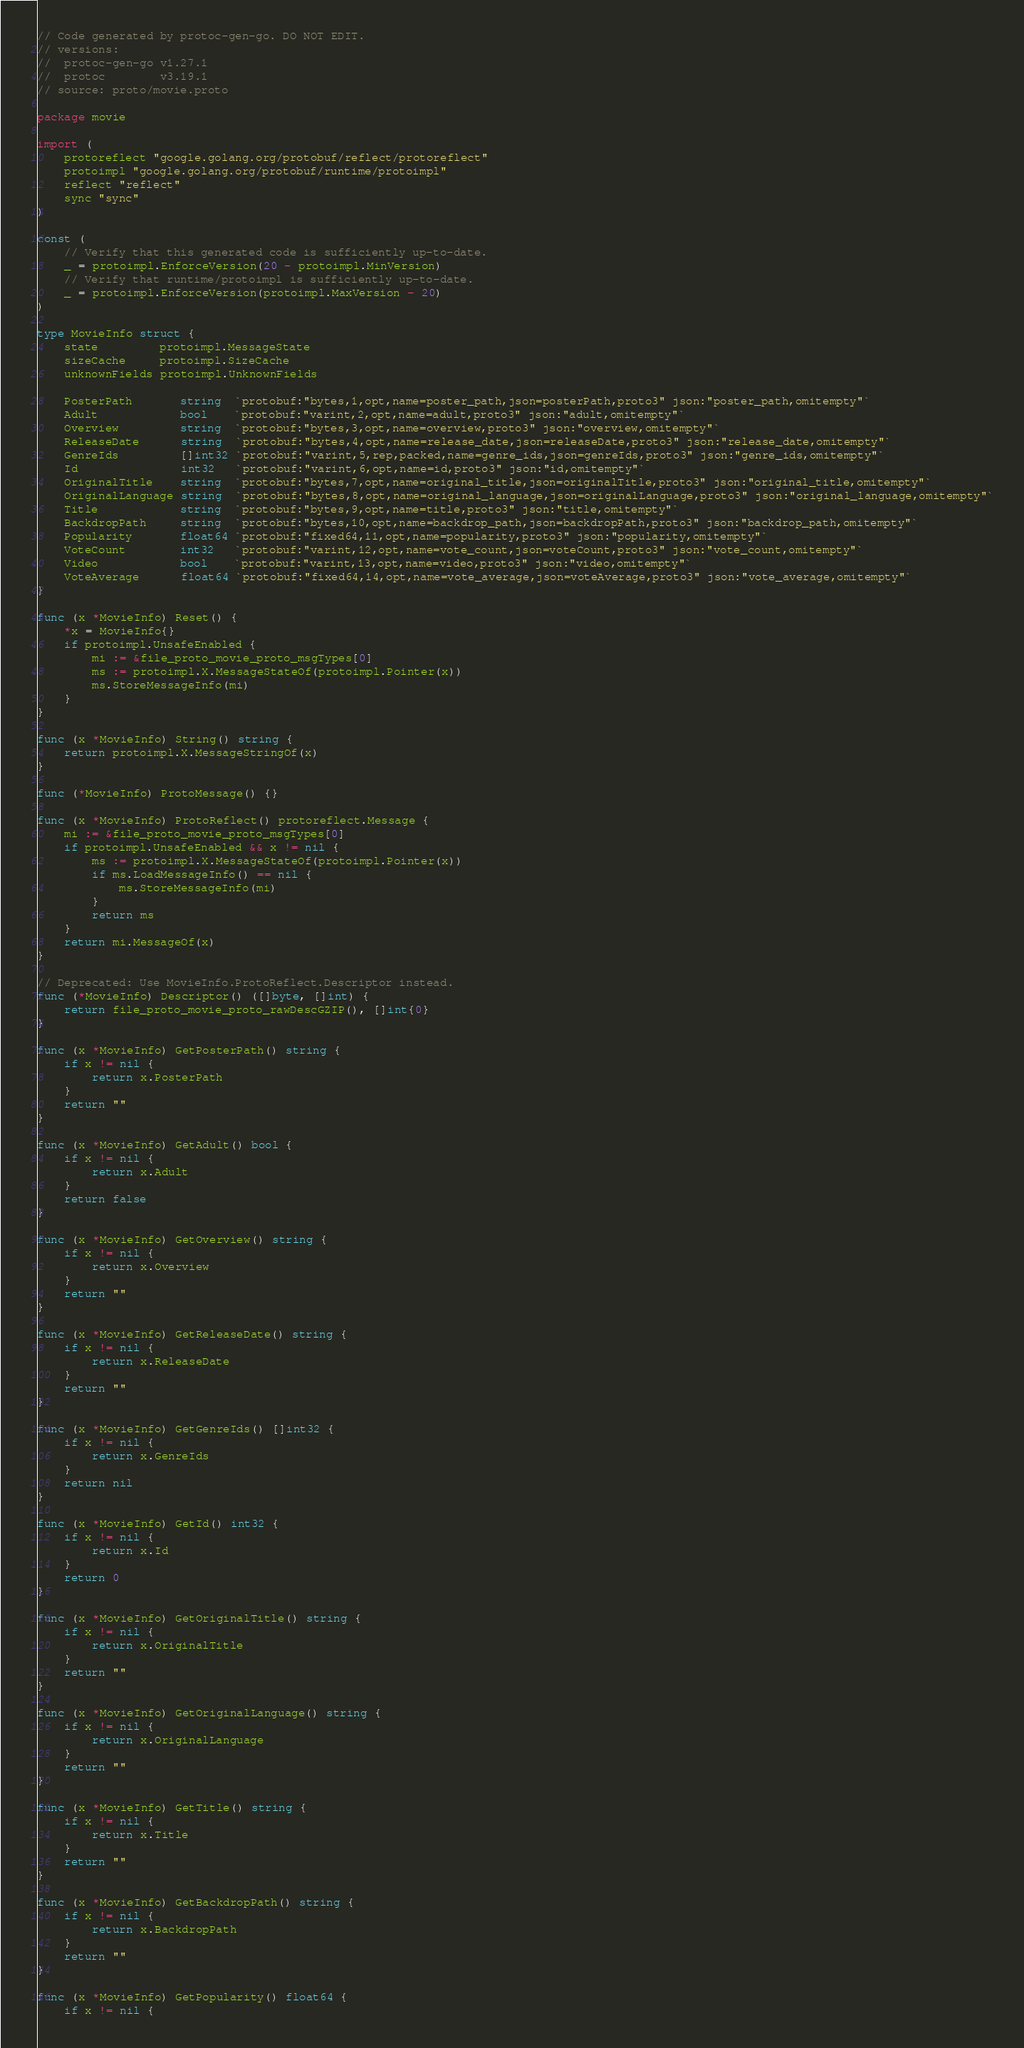Convert code to text. <code><loc_0><loc_0><loc_500><loc_500><_Go_>// Code generated by protoc-gen-go. DO NOT EDIT.
// versions:
// 	protoc-gen-go v1.27.1
// 	protoc        v3.19.1
// source: proto/movie.proto

package movie

import (
	protoreflect "google.golang.org/protobuf/reflect/protoreflect"
	protoimpl "google.golang.org/protobuf/runtime/protoimpl"
	reflect "reflect"
	sync "sync"
)

const (
	// Verify that this generated code is sufficiently up-to-date.
	_ = protoimpl.EnforceVersion(20 - protoimpl.MinVersion)
	// Verify that runtime/protoimpl is sufficiently up-to-date.
	_ = protoimpl.EnforceVersion(protoimpl.MaxVersion - 20)
)

type MovieInfo struct {
	state         protoimpl.MessageState
	sizeCache     protoimpl.SizeCache
	unknownFields protoimpl.UnknownFields

	PosterPath       string  `protobuf:"bytes,1,opt,name=poster_path,json=posterPath,proto3" json:"poster_path,omitempty"`
	Adult            bool    `protobuf:"varint,2,opt,name=adult,proto3" json:"adult,omitempty"`
	Overview         string  `protobuf:"bytes,3,opt,name=overview,proto3" json:"overview,omitempty"`
	ReleaseDate      string  `protobuf:"bytes,4,opt,name=release_date,json=releaseDate,proto3" json:"release_date,omitempty"`
	GenreIds         []int32 `protobuf:"varint,5,rep,packed,name=genre_ids,json=genreIds,proto3" json:"genre_ids,omitempty"`
	Id               int32   `protobuf:"varint,6,opt,name=id,proto3" json:"id,omitempty"`
	OriginalTitle    string  `protobuf:"bytes,7,opt,name=original_title,json=originalTitle,proto3" json:"original_title,omitempty"`
	OriginalLanguage string  `protobuf:"bytes,8,opt,name=original_language,json=originalLanguage,proto3" json:"original_language,omitempty"`
	Title            string  `protobuf:"bytes,9,opt,name=title,proto3" json:"title,omitempty"`
	BackdropPath     string  `protobuf:"bytes,10,opt,name=backdrop_path,json=backdropPath,proto3" json:"backdrop_path,omitempty"`
	Popularity       float64 `protobuf:"fixed64,11,opt,name=popularity,proto3" json:"popularity,omitempty"`
	VoteCount        int32   `protobuf:"varint,12,opt,name=vote_count,json=voteCount,proto3" json:"vote_count,omitempty"`
	Video            bool    `protobuf:"varint,13,opt,name=video,proto3" json:"video,omitempty"`
	VoteAverage      float64 `protobuf:"fixed64,14,opt,name=vote_average,json=voteAverage,proto3" json:"vote_average,omitempty"`
}

func (x *MovieInfo) Reset() {
	*x = MovieInfo{}
	if protoimpl.UnsafeEnabled {
		mi := &file_proto_movie_proto_msgTypes[0]
		ms := protoimpl.X.MessageStateOf(protoimpl.Pointer(x))
		ms.StoreMessageInfo(mi)
	}
}

func (x *MovieInfo) String() string {
	return protoimpl.X.MessageStringOf(x)
}

func (*MovieInfo) ProtoMessage() {}

func (x *MovieInfo) ProtoReflect() protoreflect.Message {
	mi := &file_proto_movie_proto_msgTypes[0]
	if protoimpl.UnsafeEnabled && x != nil {
		ms := protoimpl.X.MessageStateOf(protoimpl.Pointer(x))
		if ms.LoadMessageInfo() == nil {
			ms.StoreMessageInfo(mi)
		}
		return ms
	}
	return mi.MessageOf(x)
}

// Deprecated: Use MovieInfo.ProtoReflect.Descriptor instead.
func (*MovieInfo) Descriptor() ([]byte, []int) {
	return file_proto_movie_proto_rawDescGZIP(), []int{0}
}

func (x *MovieInfo) GetPosterPath() string {
	if x != nil {
		return x.PosterPath
	}
	return ""
}

func (x *MovieInfo) GetAdult() bool {
	if x != nil {
		return x.Adult
	}
	return false
}

func (x *MovieInfo) GetOverview() string {
	if x != nil {
		return x.Overview
	}
	return ""
}

func (x *MovieInfo) GetReleaseDate() string {
	if x != nil {
		return x.ReleaseDate
	}
	return ""
}

func (x *MovieInfo) GetGenreIds() []int32 {
	if x != nil {
		return x.GenreIds
	}
	return nil
}

func (x *MovieInfo) GetId() int32 {
	if x != nil {
		return x.Id
	}
	return 0
}

func (x *MovieInfo) GetOriginalTitle() string {
	if x != nil {
		return x.OriginalTitle
	}
	return ""
}

func (x *MovieInfo) GetOriginalLanguage() string {
	if x != nil {
		return x.OriginalLanguage
	}
	return ""
}

func (x *MovieInfo) GetTitle() string {
	if x != nil {
		return x.Title
	}
	return ""
}

func (x *MovieInfo) GetBackdropPath() string {
	if x != nil {
		return x.BackdropPath
	}
	return ""
}

func (x *MovieInfo) GetPopularity() float64 {
	if x != nil {</code> 